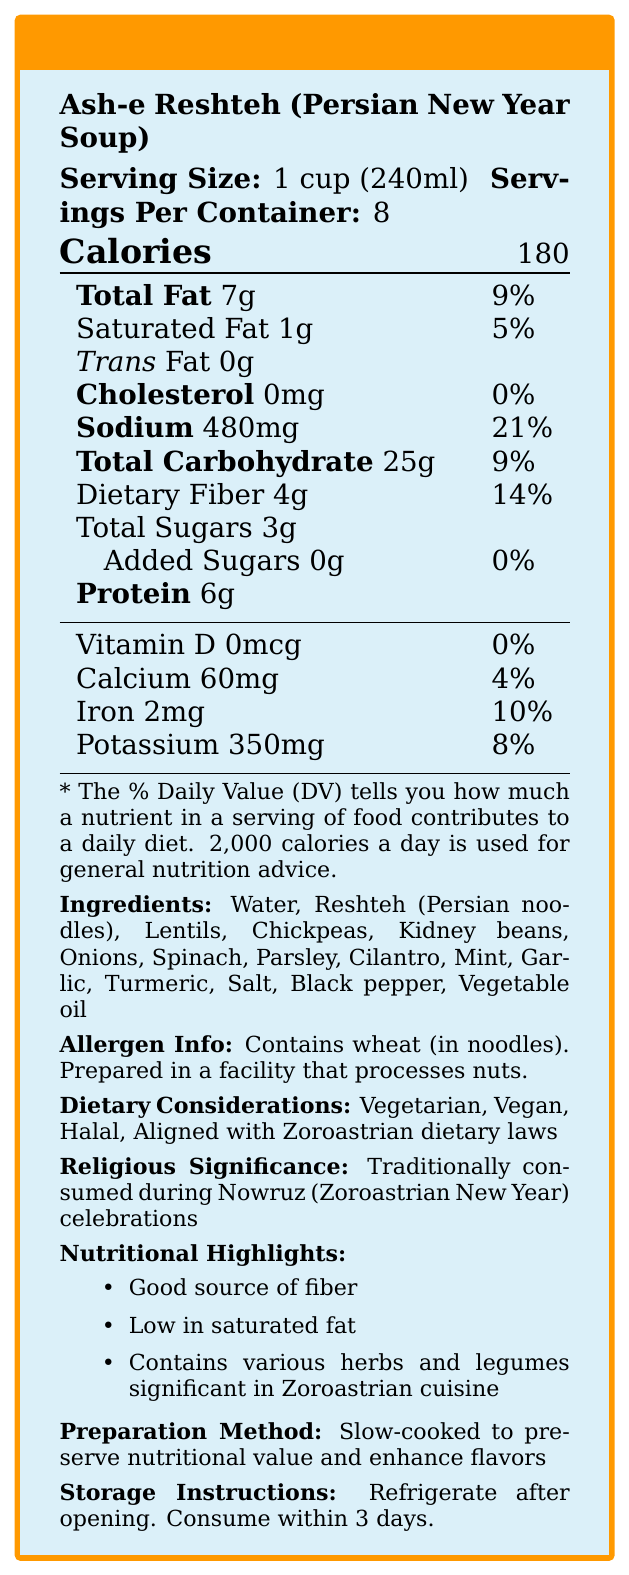what is the serving size for Ash-e Reshteh? The document states that the serving size for Ash-e Reshteh is 1 cup (240ml).
Answer: 1 cup (240ml) how many calories are there in one serving of Ash-e Reshteh? The document mentions that one serving of Ash-e Reshteh contains 180 calories.
Answer: 180 what is the sodium content per serving and its percentage of the daily value? The document lists the sodium content per serving as 480mg, which is 21% of the daily value.
Answer: 480mg, 21% how much dietary fiber is in each serving? The dietary fiber content per serving is stated as 4g in the document.
Answer: 4g name three legumes included in the ingredients of Ash-e Reshteh. The ingredients list in the document includes Lentils, Chickpeas, and Kidney beans.
Answer: Lentils, Chickpeas, Kidney beans which of the following should people allergic to wheat avoid? A. Onions B. Vegetable oil C. Reshteh noodles The allergen information specifies that the noodles contain wheat.
Answer: C. Reshteh noodles how many servings are there in one container of Ash-e Reshteh? A. 6 B. 8 C. 10 D. 12 The document states that there are 8 servings per container.
Answer: B. 8 what dietary considerations are included for Ash-e Reshteh? A. Vegetarian B. Vegan C. Aligned with Zoroastrian dietary laws D. All of the above The document lists that Ash-e Reshteh is Vegetarian, Vegan, and Aligned with Zoroastrian dietary laws along with Halal.
Answer: D. All of the above is Ash-e Reshteh high in saturated fat? The document indicates that Ash-e Reshteh is low in saturated fat.
Answer: No what is the significance of Ash-e Reshteh in Zoroastrian practices? The document mentions that Ash-e Reshteh is traditionally consumed during Nowruz celebrations.
Answer: Traditionally consumed during Nowruz (Zoroastrian New Year) celebrations summarize the nutritional highlights of Ash-e Reshteh. The document highlights that Ash-e Reshteh is a good source of fiber, low in saturated fat, and contains significant herbs and legumes.
Answer: Good source of fiber, low in saturated fat, contains various herbs and legumes significant in Zoroastrian cuisine. where should Ash-e Reshteh be stored after opening? The storage instructions in the document indicate that Ash-e Reshteh should be refrigerated after opening.
Answer: Refrigerate after opening. how is Ash-e Reshteh prepared to enhance its flavors? The preparation method described in the document states that the soup is slow-cooked.
Answer: Slow-cooked to preserve nutritional value and enhance flavors who made the Ash-e Reshteh? The document does not mention who made the Ash-e Reshteh.
Answer: Cannot be determined 